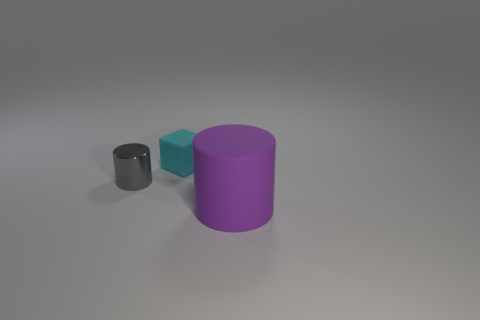What number of things are tiny matte blocks or large yellow shiny things?
Ensure brevity in your answer.  1. Are there any other things that have the same material as the gray cylinder?
Ensure brevity in your answer.  No. Are any metallic blocks visible?
Ensure brevity in your answer.  No. Do the thing that is behind the small cylinder and the purple thing have the same material?
Offer a very short reply. Yes. Are there any other small things of the same shape as the small shiny thing?
Your answer should be compact. No. Are there the same number of small gray objects on the left side of the gray object and gray shiny cubes?
Provide a succinct answer. Yes. There is a object to the right of the matte thing that is behind the small gray metal thing; what is it made of?
Keep it short and to the point. Rubber. There is a small rubber thing; what shape is it?
Ensure brevity in your answer.  Cube. Are there the same number of cyan objects that are in front of the tiny cyan rubber thing and gray objects that are on the left side of the small gray metallic object?
Offer a very short reply. Yes. Is the number of purple rubber objects that are behind the cyan cube greater than the number of tiny matte spheres?
Provide a short and direct response. No. 